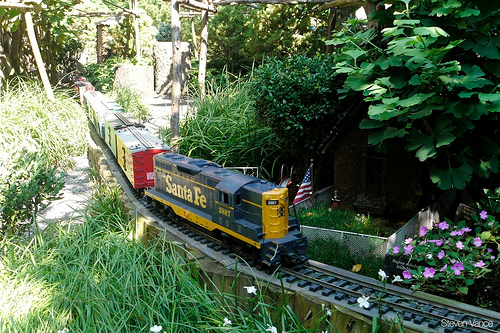Please provide a short description for this region: [0.2, 0.62, 0.24, 0.66]. This region shows part of an outdoor scenic environment. 